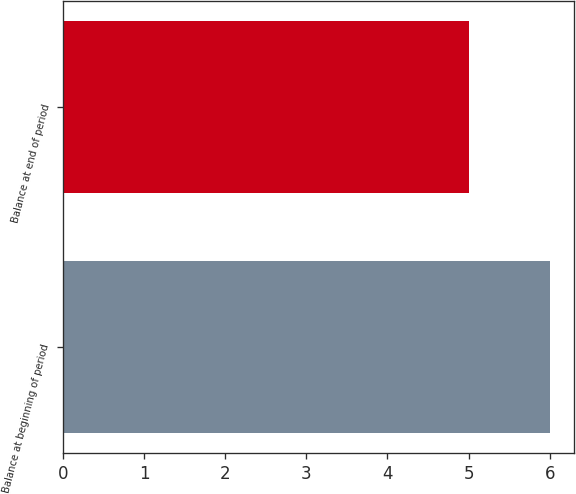Convert chart to OTSL. <chart><loc_0><loc_0><loc_500><loc_500><bar_chart><fcel>Balance at beginning of period<fcel>Balance at end of period<nl><fcel>6<fcel>5<nl></chart> 